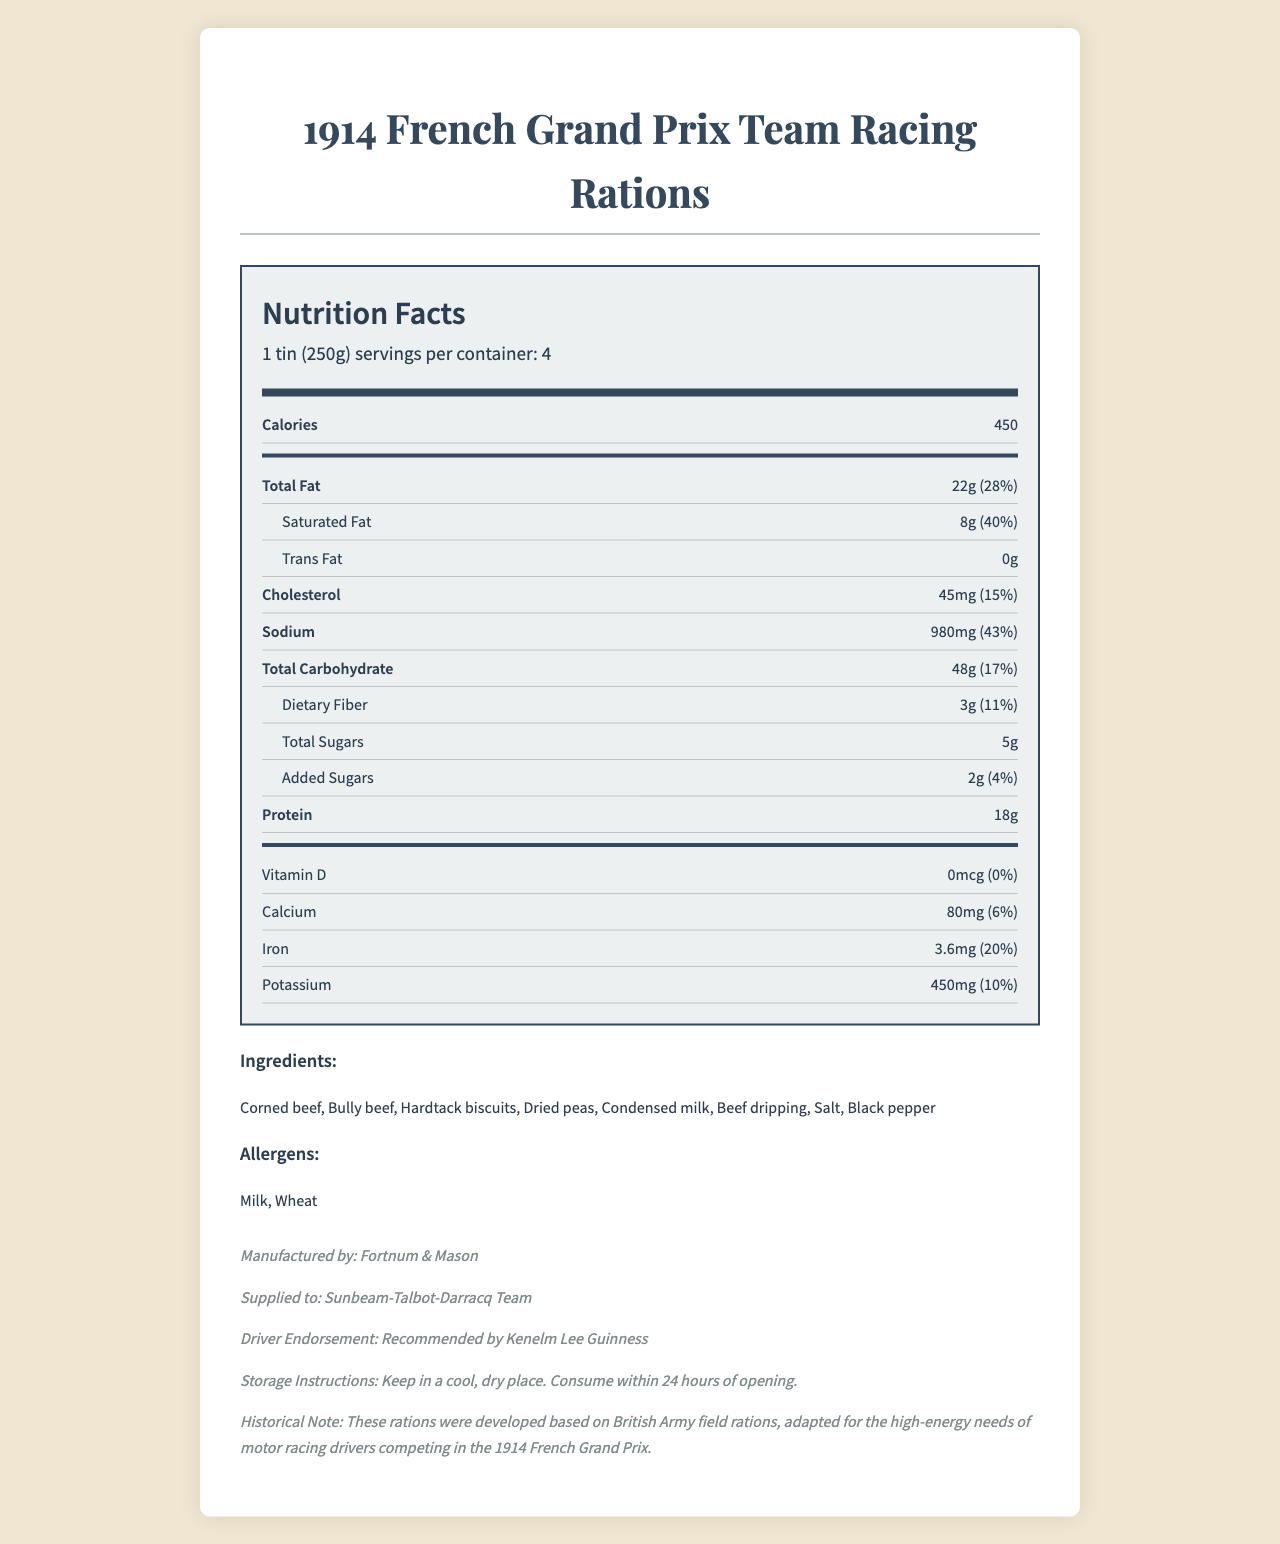who recommended the rations? The document lists Kenelm Lee Guinness under "Driver Endorsement".
Answer: Kenelm Lee Guinness how many servings are in one container? The document states "1 tin (250g) servings per container: 4".
Answer: 4 how many grams of protein are in one serving? The document shows that one serving contains 18g of protein.
Answer: 18g what is the total fat content per serving? The document lists the total fat content per serving as 22g.
Answer: 22g what type of milk ingredient is included in the rations? The listed ingredients include "Condensed milk".
Answer: Condensed milk how much sodium is in one serving of the rations? A. 450mg B. 980mg C. 600mg The sodium content per serving is 980mg according to the document.
Answer: B. 980mg which ingredient is not an allergen in these rations? A. Milk B. Wheat C. Corned beef Milk and Wheat are listed as allergens, but Corned beef is not.
Answer: C. Corned beef does the product contain any trans fat? The document states that the trans fat content is 0g per serving.
Answer: No were these rations recommended for motor racing or army use? The historical note mentions these rations as "adapted for the high-energy needs of motor racing drivers".
Answer: Motor racing what is the historical significance of the rations? The document does not provide enough information to determine the historical significance beyond their use in the 1914 French Grand Prix.
Answer: Not enough information who manufactured the rations? The manufacturer is listed as Fortnum & Mason in the additional info section.
Answer: Fortnum & Mason describe the main idea of the document. The document serves as a comprehensive nutrition label for the 1914 French Grand Prix Team Racing Rations, including all the necessary details for understanding its contents and nutritional benefits, along with historical context.
Answer: The document provides detailed nutritional information about the rations supplied to British motor racing teams during the 1914 French Grand Prix. It includes serving size, nutritional values, ingredients, allergens, and additional information about the manufacturer, endorsement, and storage instructions. what is the percentage of daily value for iron in one serving? The document lists the daily value percentage for iron as 20%.
Answer: 20% what is the serving size for the rations? The serving size is specified as 1 tin (250g).
Answer: 1 tin (250g) how many grams of total carbohydrates are there per serving? The document shows that each serving contains 48g of total carbohydrates.
Answer: 48g what are the storage instructions for the rations? The additional info section specifies these storage instructions.
Answer: Keep in a cool, dry place. Consume within 24 hours of opening. 